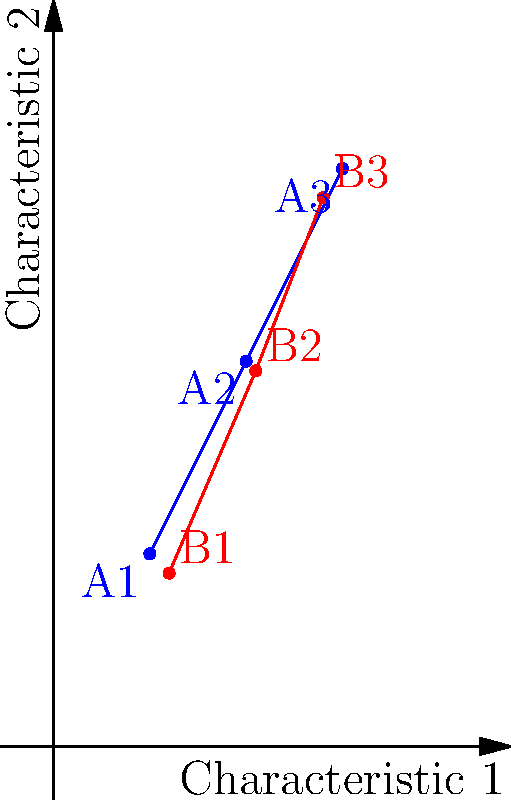As an anthropology student inspired by Carole E. Hill's work on quantitative methods in archaeology, you're analyzing the similarity between two sets of archaeological artifacts. Each artifact is represented by a 3D vector based on three characteristics. The blue points (A1, A2, A3) represent one set of artifacts, while the red points (B1, B2, B3) represent another. Given the vectors $\vec{a} = (1, 2, 3)$ and $\vec{b} = (1.2, 2.1, 2.8)$, calculate the cosine similarity between these two artifact sets using the dot product formula. Round your answer to three decimal places. To solve this problem, we'll follow these steps:

1) Recall the formula for cosine similarity using dot product:
   $$\cos \theta = \frac{\vec{a} \cdot \vec{b}}{|\vec{a}||\vec{b}|}$$

2) Calculate the dot product $\vec{a} \cdot \vec{b}$:
   $\vec{a} \cdot \vec{b} = (1)(1.2) + (2)(2.1) + (3)(2.8)$
   $= 1.2 + 4.2 + 8.4 = 13.8$

3) Calculate $|\vec{a}|$:
   $|\vec{a}| = \sqrt{1^2 + 2^2 + 3^2} = \sqrt{14}$

4) Calculate $|\vec{b}|$:
   $|\vec{b}| = \sqrt{1.2^2 + 2.1^2 + 2.8^2} = \sqrt{13.69}$

5) Now, let's put it all together:
   $$\cos \theta = \frac{13.8}{\sqrt{14} \cdot \sqrt{13.69}}$$

6) Calculate the final result:
   $$\cos \theta = \frac{13.8}{\sqrt{191.66}} = \frac{13.8}{13.844} \approx 0.9968$$

7) Rounding to three decimal places: 0.997

This high cosine similarity (very close to 1) indicates that the two sets of artifacts are very similar in terms of the measured characteristics.
Answer: 0.997 